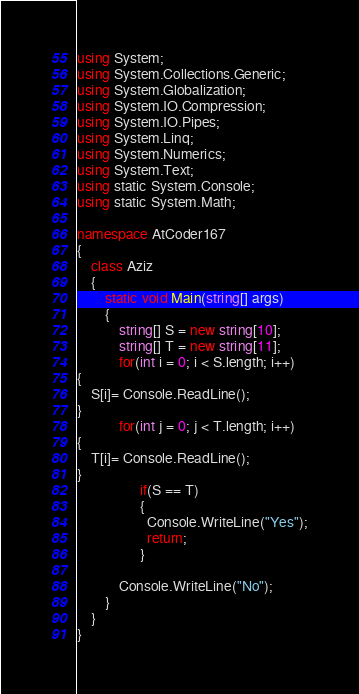Convert code to text. <code><loc_0><loc_0><loc_500><loc_500><_C#_>using System;
using System.Collections.Generic;
using System.Globalization;
using System.IO.Compression;
using System.IO.Pipes;
using System.Linq;
using System.Numerics;
using System.Text;
using static System.Console;
using static System.Math;
 
namespace AtCoder167
{
    class Aziz
    {
        static void Main(string[] args)
        {
            string[] S = new string[10];
            string[] T = new string[11];
            for(int i = 0; i < S.length; i++)
{
    S[i]= Console.ReadLine();
}  
            for(int j = 0; j < T.length; i++)
{
    T[i]= Console.ReadLine();
}
                  if(S == T)
                  {
                    Console.WriteLine("Yes");
                    return;
                  }      
            
            Console.WriteLine("No");
        }
    }
}
</code> 